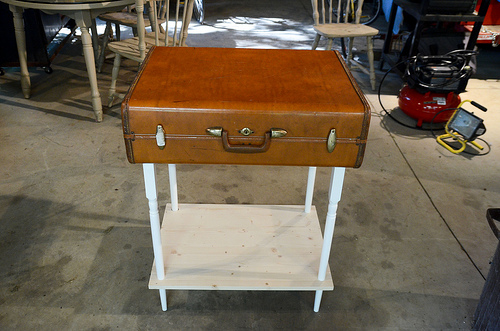<image>
Is the suitcase under the chair? No. The suitcase is not positioned under the chair. The vertical relationship between these objects is different. 